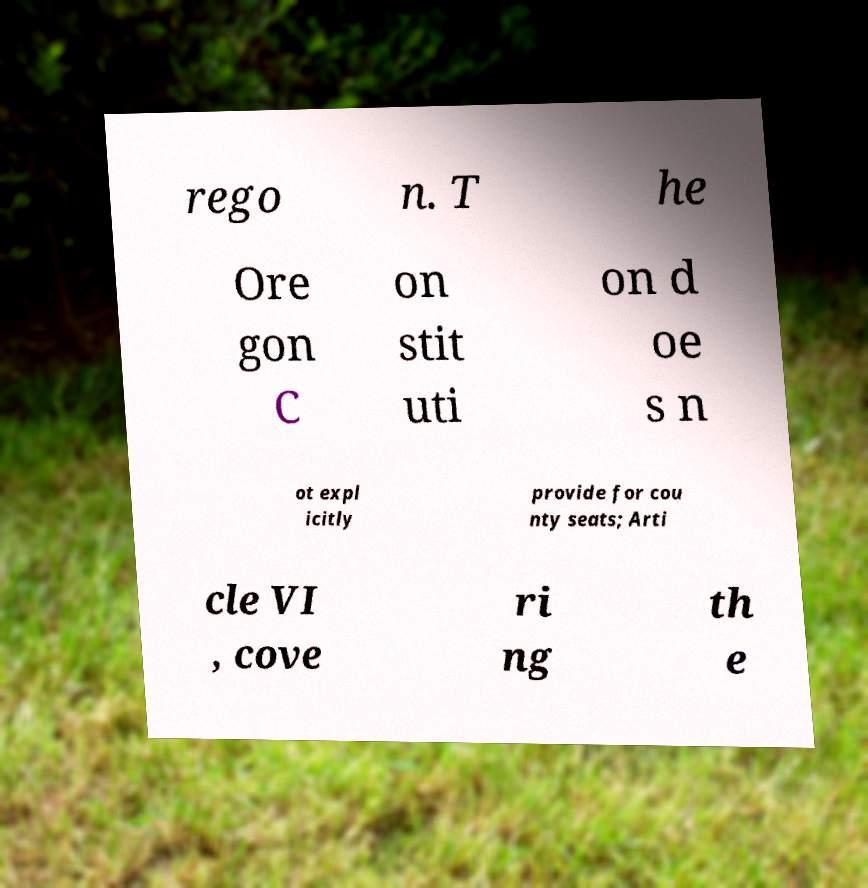I need the written content from this picture converted into text. Can you do that? rego n. T he Ore gon C on stit uti on d oe s n ot expl icitly provide for cou nty seats; Arti cle VI , cove ri ng th e 